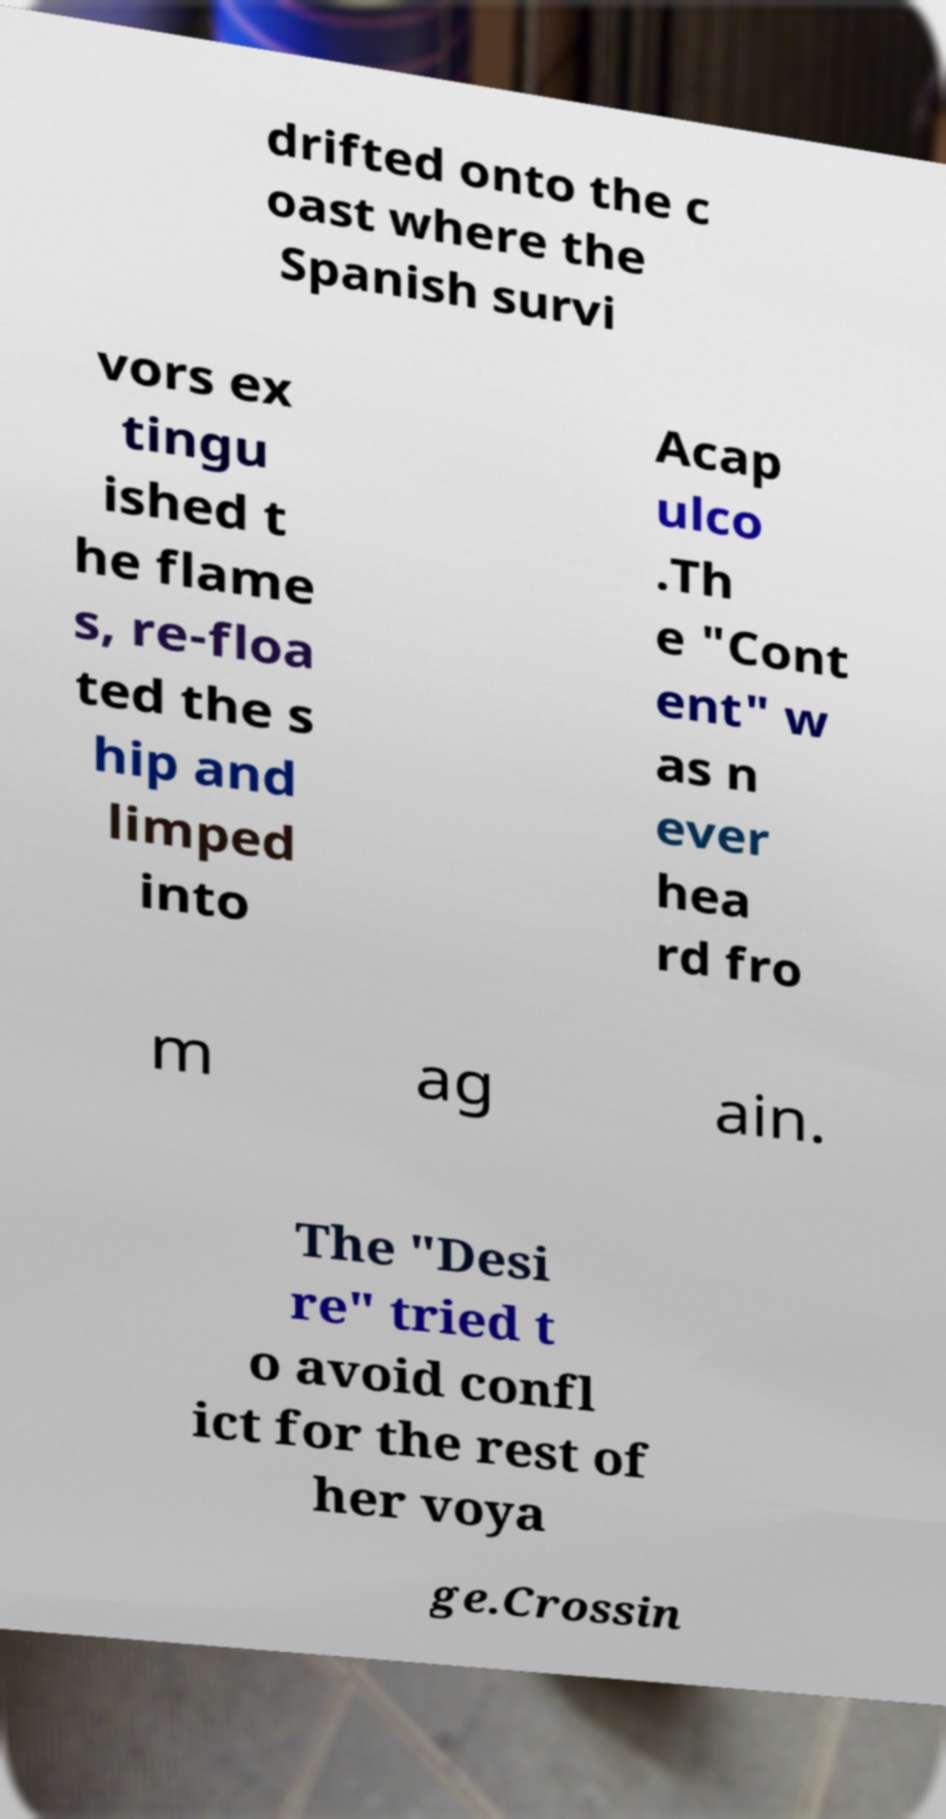What messages or text are displayed in this image? I need them in a readable, typed format. drifted onto the c oast where the Spanish survi vors ex tingu ished t he flame s, re-floa ted the s hip and limped into Acap ulco .Th e "Cont ent" w as n ever hea rd fro m ag ain. The "Desi re" tried t o avoid confl ict for the rest of her voya ge.Crossin 